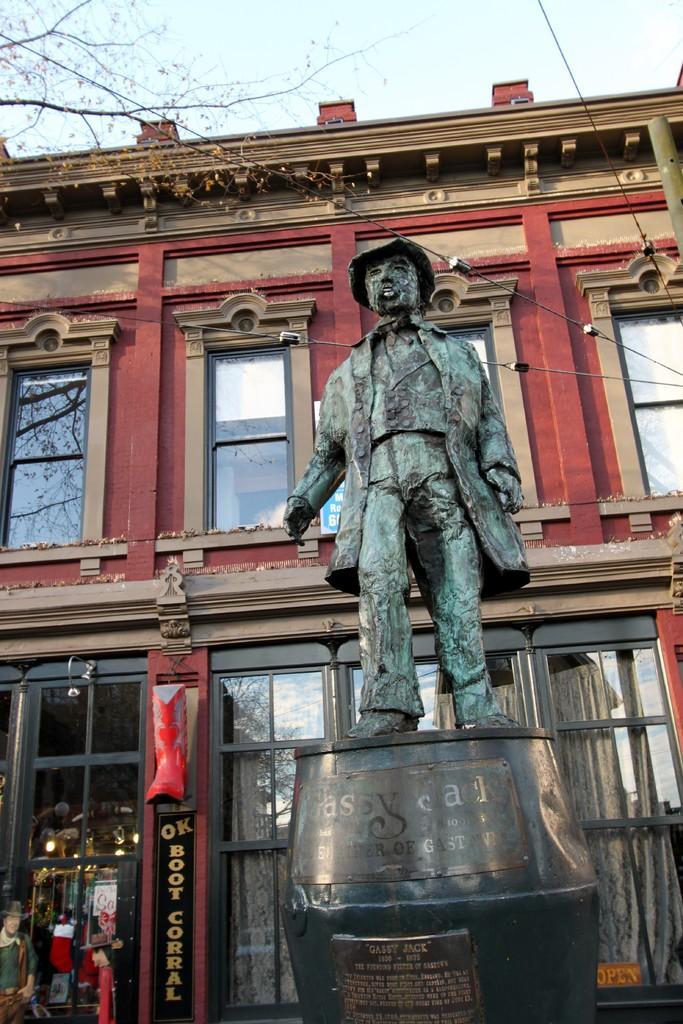Can you describe this image briefly? In this image, I can see a statue of a person, which is in front of a building. At the top of the image, I can see the tree branches and the sky. 